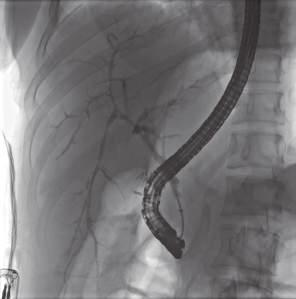what is entrapped in a dense, onion-skin concentric scar?
Answer the question using a single word or phrase. A bile duct undergoing degeneration 